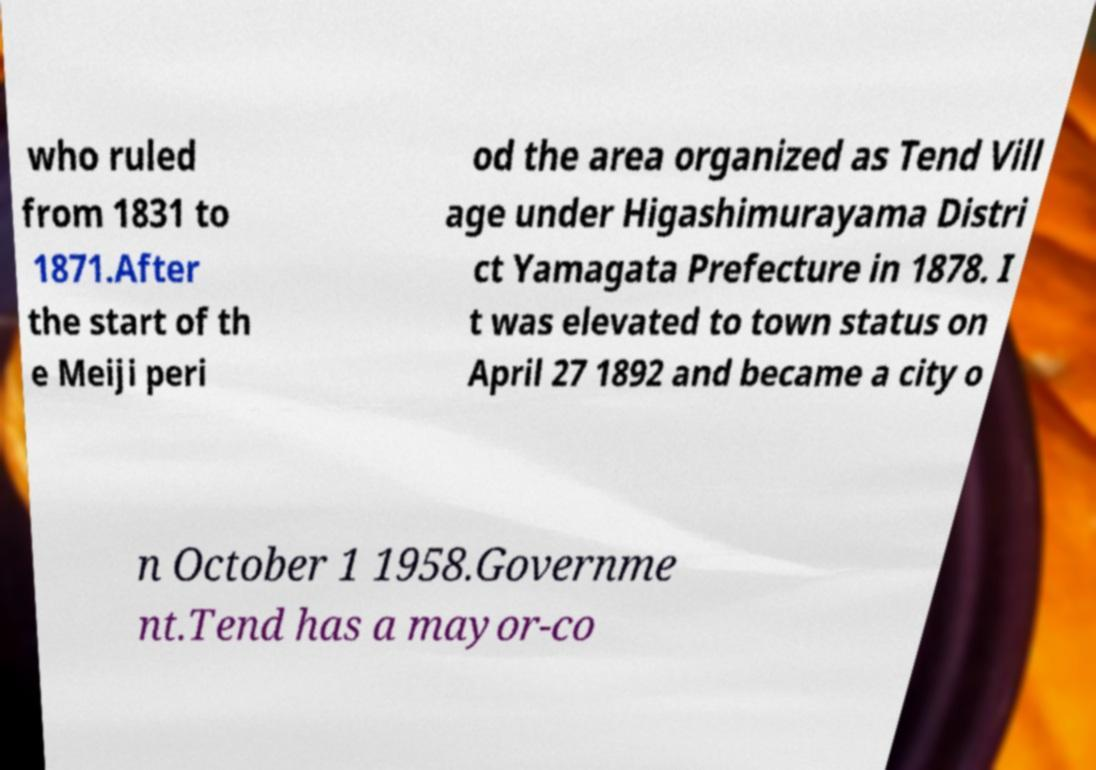Can you accurately transcribe the text from the provided image for me? who ruled from 1831 to 1871.After the start of th e Meiji peri od the area organized as Tend Vill age under Higashimurayama Distri ct Yamagata Prefecture in 1878. I t was elevated to town status on April 27 1892 and became a city o n October 1 1958.Governme nt.Tend has a mayor-co 